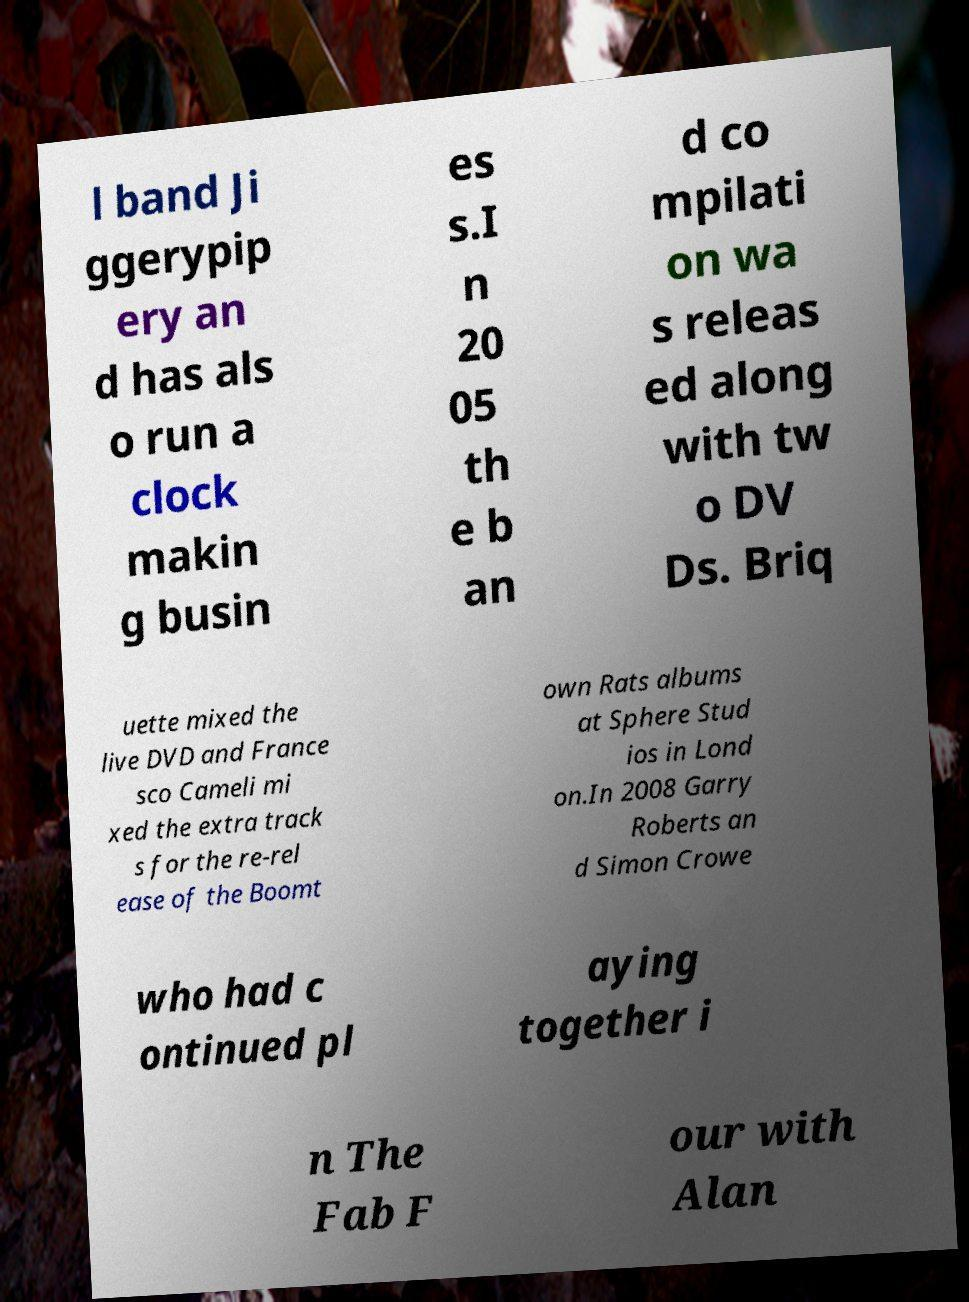Can you read and provide the text displayed in the image?This photo seems to have some interesting text. Can you extract and type it out for me? l band Ji ggerypip ery an d has als o run a clock makin g busin es s.I n 20 05 th e b an d co mpilati on wa s releas ed along with tw o DV Ds. Briq uette mixed the live DVD and France sco Cameli mi xed the extra track s for the re-rel ease of the Boomt own Rats albums at Sphere Stud ios in Lond on.In 2008 Garry Roberts an d Simon Crowe who had c ontinued pl aying together i n The Fab F our with Alan 